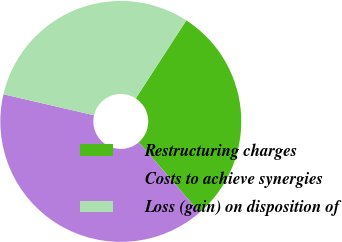Convert chart to OTSL. <chart><loc_0><loc_0><loc_500><loc_500><pie_chart><fcel>Restructuring charges<fcel>Costs to achieve synergies<fcel>Loss (gain) on disposition of<nl><fcel>29.48%<fcel>39.98%<fcel>30.53%<nl></chart> 